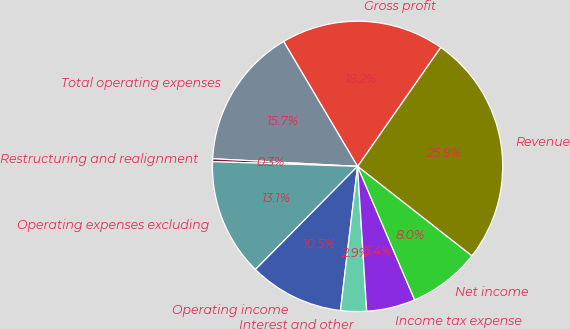Convert chart to OTSL. <chart><loc_0><loc_0><loc_500><loc_500><pie_chart><fcel>Revenue<fcel>Gross profit<fcel>Total operating expenses<fcel>Restructuring and realignment<fcel>Operating expenses excluding<fcel>Operating income<fcel>Interest and other<fcel>Income tax expense<fcel>Net income<nl><fcel>25.87%<fcel>18.21%<fcel>15.65%<fcel>0.32%<fcel>13.1%<fcel>10.54%<fcel>2.88%<fcel>5.43%<fcel>7.99%<nl></chart> 